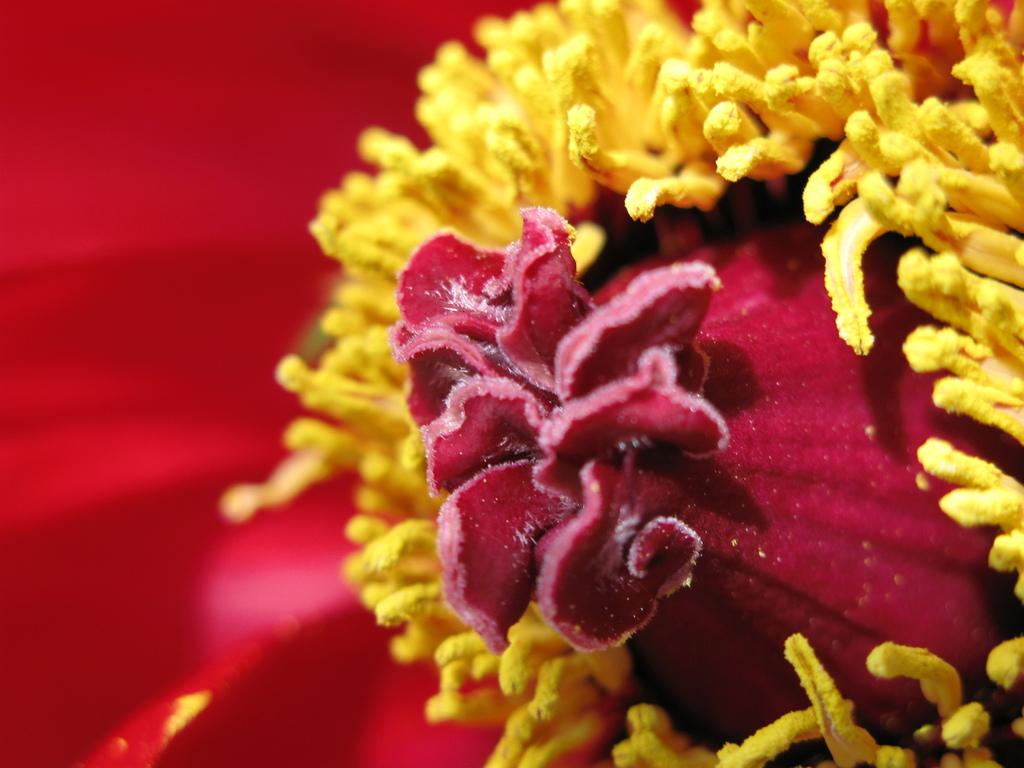What is the main subject of the image? The main subject of the image is a flower. Can you describe the condition of the flower? The flower is truncated or incomplete. What type of light is being used to illuminate the rake in the image? There is no rake present in the image, and therefore no light is being used to illuminate it. 